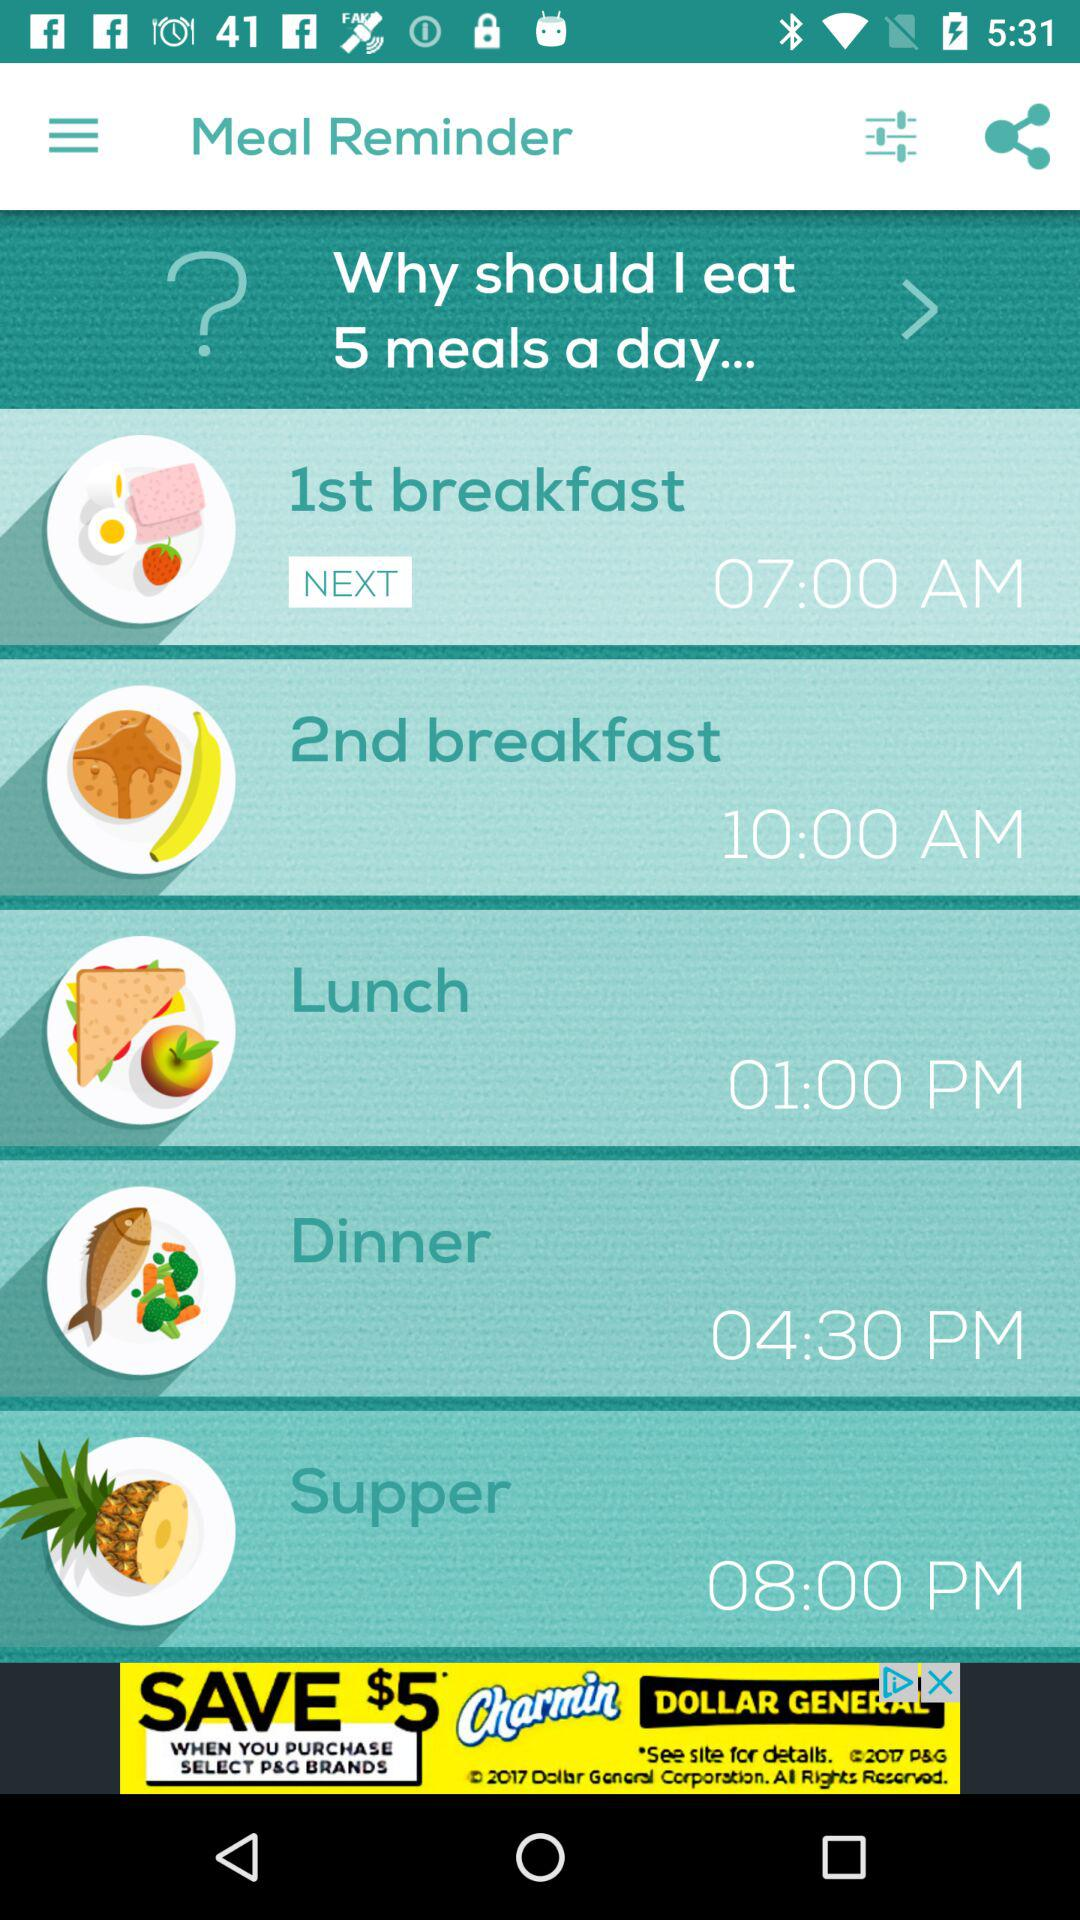What are the benefits of having five smaller meals throughout the day instead of three larger ones? Eating five smaller meals can boost metabolism, reduce hunger pangs, and provide consistent energy levels throughout the day, helping to manage weight and improve nutrition intake. 